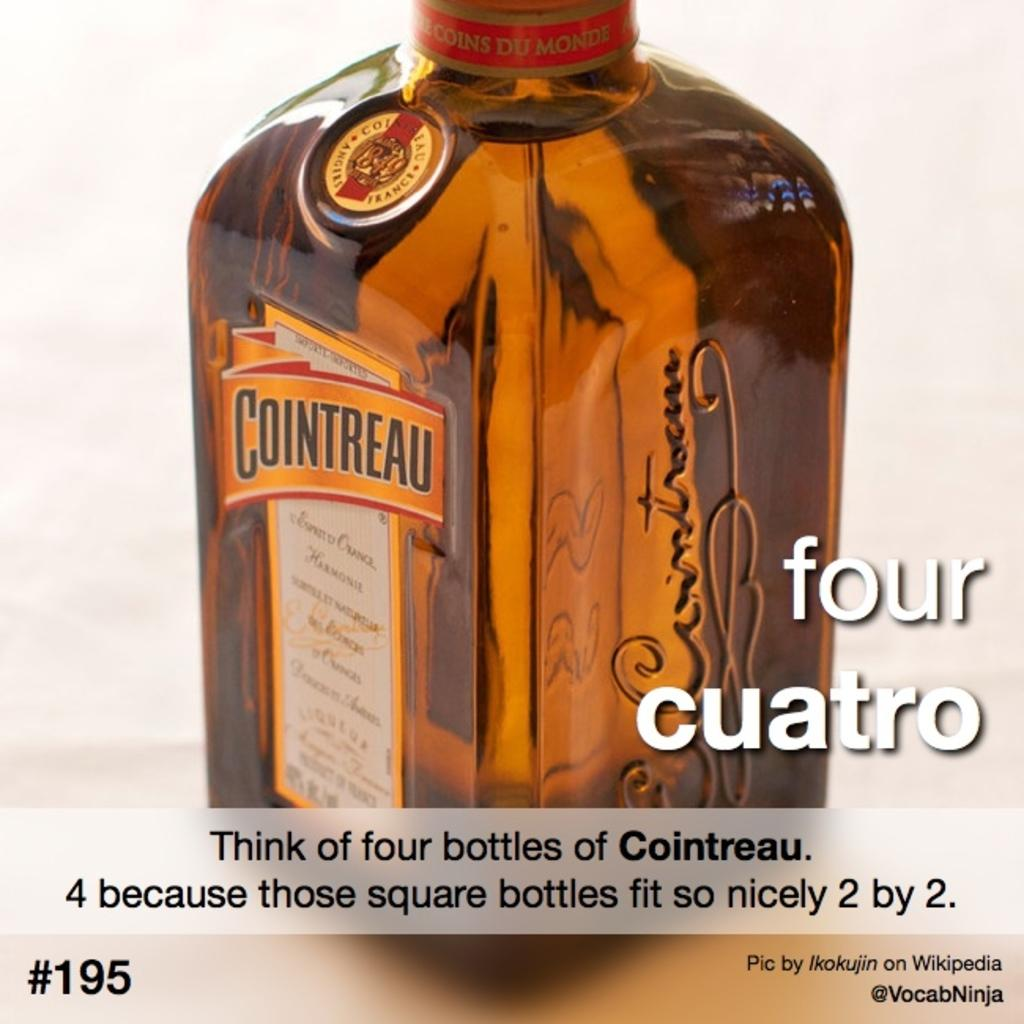<image>
Give a short and clear explanation of the subsequent image. a bottle of cointreau with a description of how to count to four 